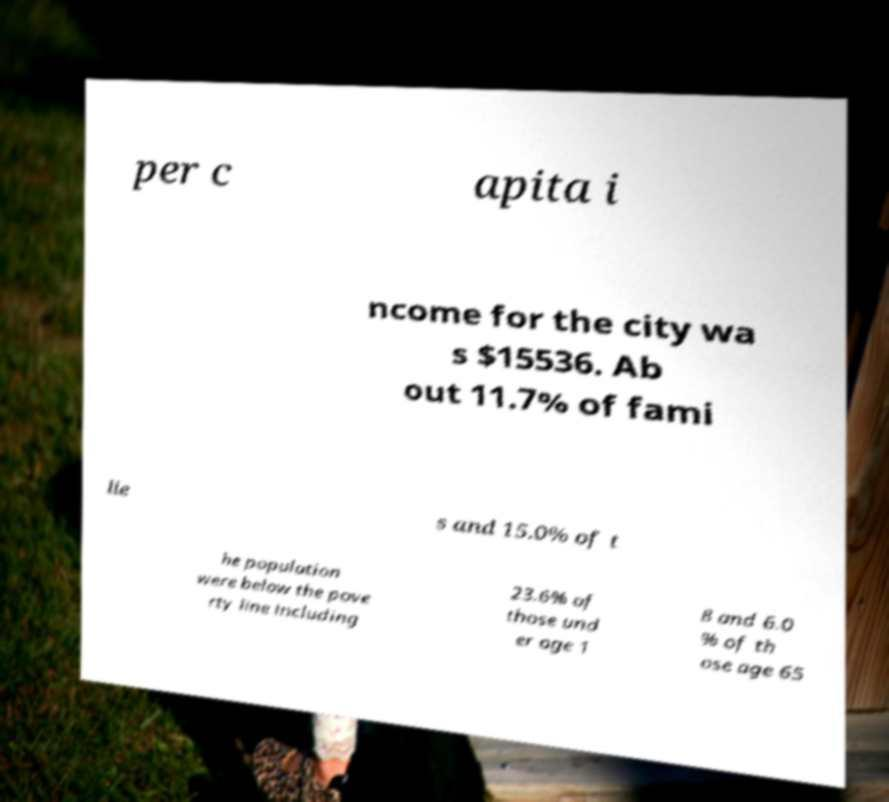What messages or text are displayed in this image? I need them in a readable, typed format. per c apita i ncome for the city wa s $15536. Ab out 11.7% of fami lie s and 15.0% of t he population were below the pove rty line including 23.6% of those und er age 1 8 and 6.0 % of th ose age 65 